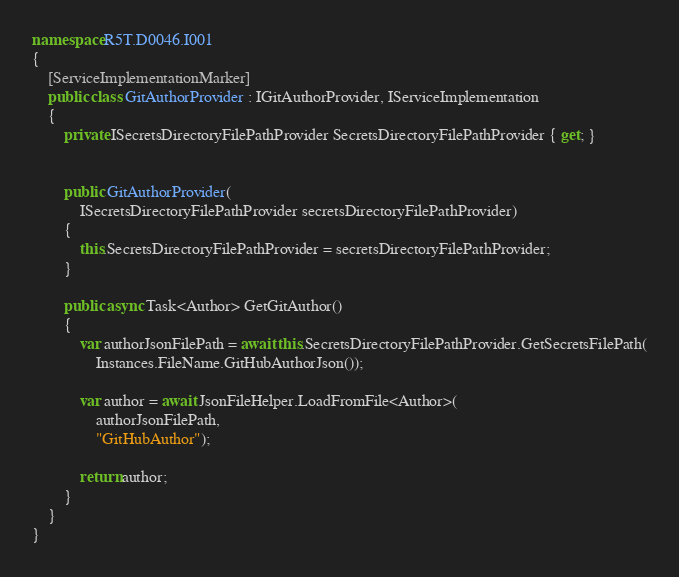<code> <loc_0><loc_0><loc_500><loc_500><_C#_>

namespace R5T.D0046.I001
{
    [ServiceImplementationMarker]
    public class GitAuthorProvider : IGitAuthorProvider, IServiceImplementation
    {
        private ISecretsDirectoryFilePathProvider SecretsDirectoryFilePathProvider { get; }


        public GitAuthorProvider(
            ISecretsDirectoryFilePathProvider secretsDirectoryFilePathProvider)
        {
            this.SecretsDirectoryFilePathProvider = secretsDirectoryFilePathProvider;
        }

        public async Task<Author> GetGitAuthor()
        {
            var authorJsonFilePath = await this.SecretsDirectoryFilePathProvider.GetSecretsFilePath(
                Instances.FileName.GitHubAuthorJson());

            var author = await JsonFileHelper.LoadFromFile<Author>(
                authorJsonFilePath,
                "GitHubAuthor");

            return author;
        }
    }
}</code> 